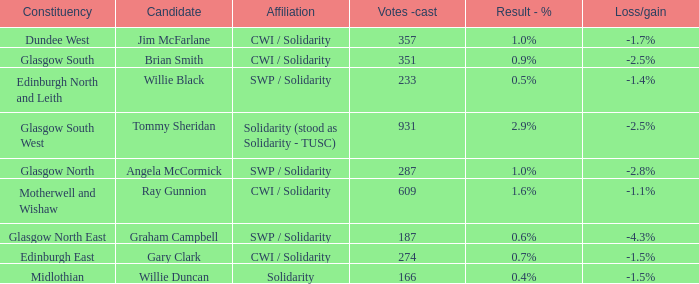Can you give me this table as a dict? {'header': ['Constituency', 'Candidate', 'Affiliation', 'Votes -cast', 'Result - %', 'Loss/gain'], 'rows': [['Dundee West', 'Jim McFarlane', 'CWI / Solidarity', '357', '1.0%', '-1.7%'], ['Glasgow South', 'Brian Smith', 'CWI / Solidarity', '351', '0.9%', '-2.5%'], ['Edinburgh North and Leith', 'Willie Black', 'SWP / Solidarity', '233', '0.5%', '-1.4%'], ['Glasgow South West', 'Tommy Sheridan', 'Solidarity (stood as Solidarity - TUSC)', '931', '2.9%', '-2.5%'], ['Glasgow North', 'Angela McCormick', 'SWP / Solidarity', '287', '1.0%', '-2.8%'], ['Motherwell and Wishaw', 'Ray Gunnion', 'CWI / Solidarity', '609', '1.6%', '-1.1%'], ['Glasgow North East', 'Graham Campbell', 'SWP / Solidarity', '187', '0.6%', '-4.3%'], ['Edinburgh East', 'Gary Clark', 'CWI / Solidarity', '274', '0.7%', '-1.5%'], ['Midlothian', 'Willie Duncan', 'Solidarity', '166', '0.4%', '-1.5%']]} What was the loss or gain when the association was united? -1.5%. 